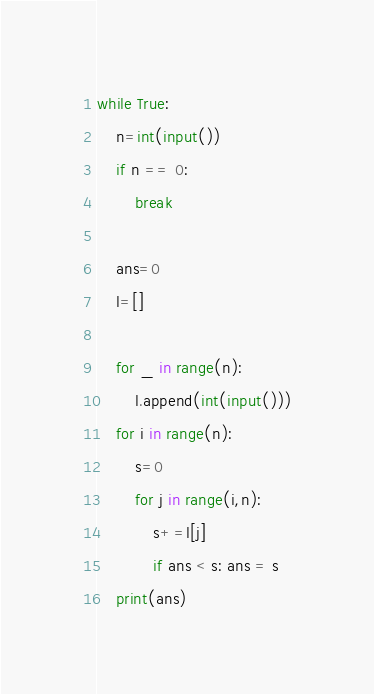<code> <loc_0><loc_0><loc_500><loc_500><_Python_>while True:
    n=int(input())
    if n == 0:
        break

    ans=0
    l=[]

    for _ in range(n):
        l.append(int(input()))
    for i in range(n):
        s=0
        for j in range(i,n):
            s+=l[j]
            if ans < s: ans = s
    print(ans)</code> 